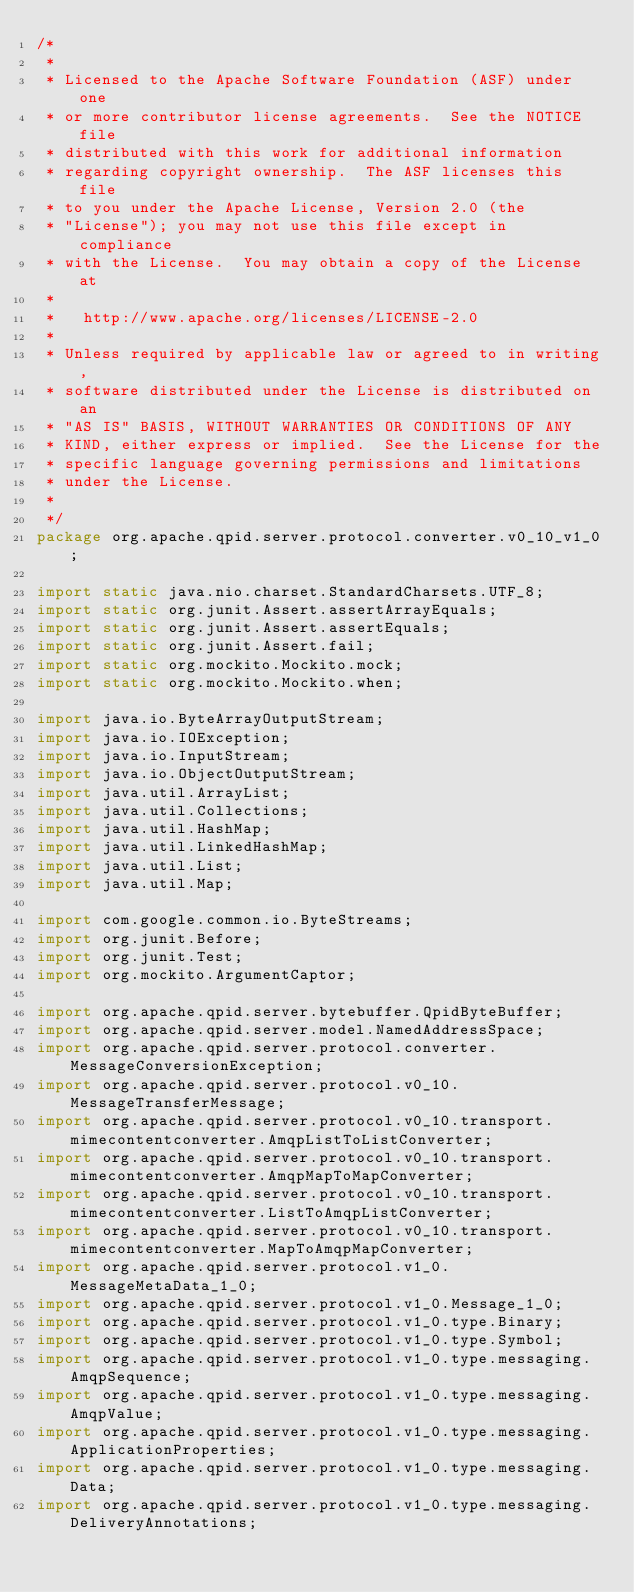<code> <loc_0><loc_0><loc_500><loc_500><_Java_>/*
 *
 * Licensed to the Apache Software Foundation (ASF) under one
 * or more contributor license agreements.  See the NOTICE file
 * distributed with this work for additional information
 * regarding copyright ownership.  The ASF licenses this file
 * to you under the Apache License, Version 2.0 (the
 * "License"); you may not use this file except in compliance
 * with the License.  You may obtain a copy of the License at
 *
 *   http://www.apache.org/licenses/LICENSE-2.0
 *
 * Unless required by applicable law or agreed to in writing,
 * software distributed under the License is distributed on an
 * "AS IS" BASIS, WITHOUT WARRANTIES OR CONDITIONS OF ANY
 * KIND, either express or implied.  See the License for the
 * specific language governing permissions and limitations
 * under the License.
 *
 */
package org.apache.qpid.server.protocol.converter.v0_10_v1_0;

import static java.nio.charset.StandardCharsets.UTF_8;
import static org.junit.Assert.assertArrayEquals;
import static org.junit.Assert.assertEquals;
import static org.junit.Assert.fail;
import static org.mockito.Mockito.mock;
import static org.mockito.Mockito.when;

import java.io.ByteArrayOutputStream;
import java.io.IOException;
import java.io.InputStream;
import java.io.ObjectOutputStream;
import java.util.ArrayList;
import java.util.Collections;
import java.util.HashMap;
import java.util.LinkedHashMap;
import java.util.List;
import java.util.Map;

import com.google.common.io.ByteStreams;
import org.junit.Before;
import org.junit.Test;
import org.mockito.ArgumentCaptor;

import org.apache.qpid.server.bytebuffer.QpidByteBuffer;
import org.apache.qpid.server.model.NamedAddressSpace;
import org.apache.qpid.server.protocol.converter.MessageConversionException;
import org.apache.qpid.server.protocol.v0_10.MessageTransferMessage;
import org.apache.qpid.server.protocol.v0_10.transport.mimecontentconverter.AmqpListToListConverter;
import org.apache.qpid.server.protocol.v0_10.transport.mimecontentconverter.AmqpMapToMapConverter;
import org.apache.qpid.server.protocol.v0_10.transport.mimecontentconverter.ListToAmqpListConverter;
import org.apache.qpid.server.protocol.v0_10.transport.mimecontentconverter.MapToAmqpMapConverter;
import org.apache.qpid.server.protocol.v1_0.MessageMetaData_1_0;
import org.apache.qpid.server.protocol.v1_0.Message_1_0;
import org.apache.qpid.server.protocol.v1_0.type.Binary;
import org.apache.qpid.server.protocol.v1_0.type.Symbol;
import org.apache.qpid.server.protocol.v1_0.type.messaging.AmqpSequence;
import org.apache.qpid.server.protocol.v1_0.type.messaging.AmqpValue;
import org.apache.qpid.server.protocol.v1_0.type.messaging.ApplicationProperties;
import org.apache.qpid.server.protocol.v1_0.type.messaging.Data;
import org.apache.qpid.server.protocol.v1_0.type.messaging.DeliveryAnnotations;</code> 